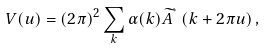Convert formula to latex. <formula><loc_0><loc_0><loc_500><loc_500>V ( { u } ) = ( 2 \pi ) ^ { 2 } \sum _ { k } \alpha ( { k } ) \widetilde { A } ^ { ^ { * } } \left ( { k } + 2 \pi { u } \right ) ,</formula> 